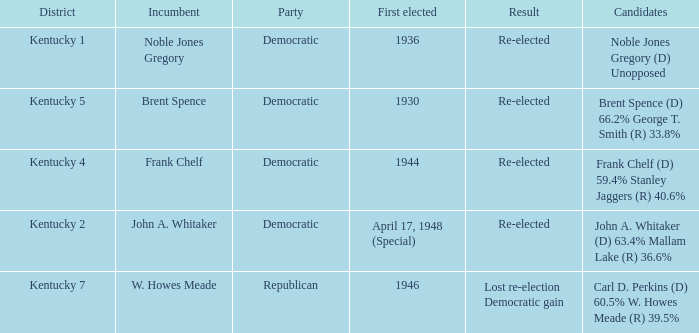List all candidates in the democratic party where the election had the incumbent Frank Chelf running. Frank Chelf (D) 59.4% Stanley Jaggers (R) 40.6%. 